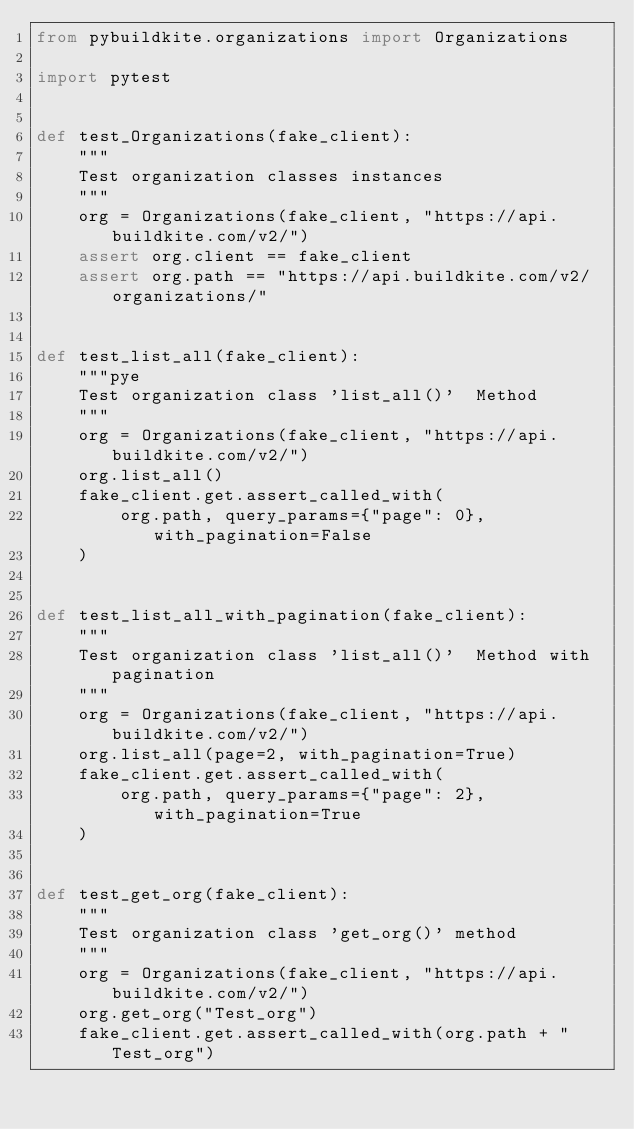<code> <loc_0><loc_0><loc_500><loc_500><_Python_>from pybuildkite.organizations import Organizations

import pytest


def test_Organizations(fake_client):
    """
    Test organization classes instances
    """
    org = Organizations(fake_client, "https://api.buildkite.com/v2/")
    assert org.client == fake_client
    assert org.path == "https://api.buildkite.com/v2/organizations/"


def test_list_all(fake_client):
    """pye
    Test organization class 'list_all()'  Method
    """
    org = Organizations(fake_client, "https://api.buildkite.com/v2/")
    org.list_all()
    fake_client.get.assert_called_with(
        org.path, query_params={"page": 0}, with_pagination=False
    )


def test_list_all_with_pagination(fake_client):
    """
    Test organization class 'list_all()'  Method with pagination
    """
    org = Organizations(fake_client, "https://api.buildkite.com/v2/")
    org.list_all(page=2, with_pagination=True)
    fake_client.get.assert_called_with(
        org.path, query_params={"page": 2}, with_pagination=True
    )


def test_get_org(fake_client):
    """
    Test organization class 'get_org()' method
    """
    org = Organizations(fake_client, "https://api.buildkite.com/v2/")
    org.get_org("Test_org")
    fake_client.get.assert_called_with(org.path + "Test_org")
</code> 